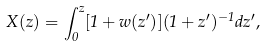Convert formula to latex. <formula><loc_0><loc_0><loc_500><loc_500>X ( z ) = \int _ { 0 } ^ { z } [ 1 + w ( z ^ { \prime } ) ] ( 1 + z ^ { \prime } ) ^ { - 1 } d z ^ { \prime } ,</formula> 